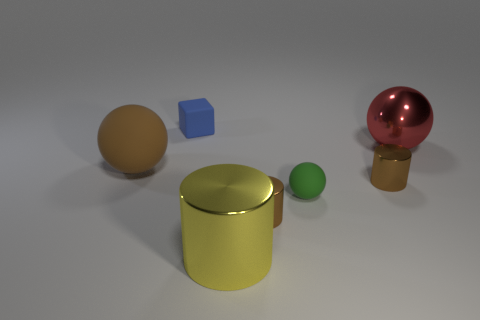How does the lighting in the image affect the appearance of the objects? The lighting in the image is soft and diffused, coming from what seems to be an overhead source. It creates gentle shadows that lend a three-dimensional quality to the objects, emphasizing their shapes without causing harsh reflections. The metallic surfaces, particularly the cylinder and the red sphere, show the light reflections prominently, making their materials appear shiny and smooth, while the matte surfaces of the cube and the tan sphere absorb the light, showing fewer highlights and more subtle texture. 